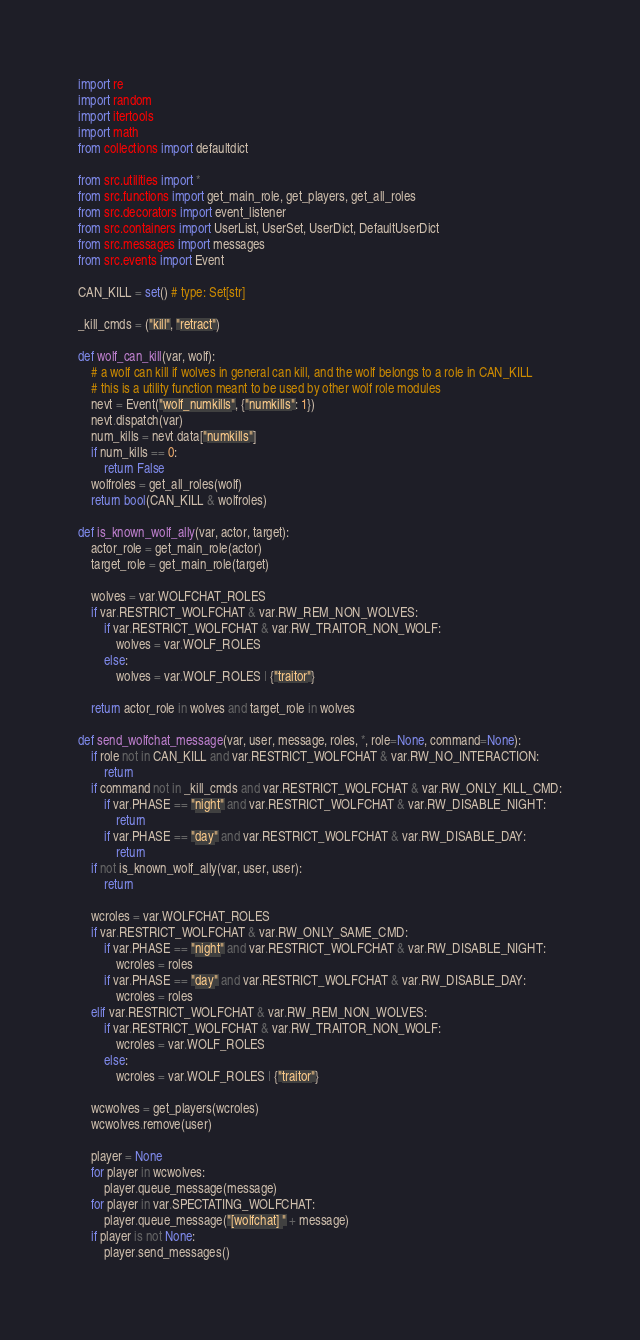<code> <loc_0><loc_0><loc_500><loc_500><_Python_>import re
import random
import itertools
import math
from collections import defaultdict

from src.utilities import *
from src.functions import get_main_role, get_players, get_all_roles
from src.decorators import event_listener
from src.containers import UserList, UserSet, UserDict, DefaultUserDict
from src.messages import messages
from src.events import Event

CAN_KILL = set() # type: Set[str]

_kill_cmds = ("kill", "retract")

def wolf_can_kill(var, wolf):
    # a wolf can kill if wolves in general can kill, and the wolf belongs to a role in CAN_KILL
    # this is a utility function meant to be used by other wolf role modules
    nevt = Event("wolf_numkills", {"numkills": 1})
    nevt.dispatch(var)
    num_kills = nevt.data["numkills"]
    if num_kills == 0:
        return False
    wolfroles = get_all_roles(wolf)
    return bool(CAN_KILL & wolfroles)

def is_known_wolf_ally(var, actor, target):
    actor_role = get_main_role(actor)
    target_role = get_main_role(target)

    wolves = var.WOLFCHAT_ROLES
    if var.RESTRICT_WOLFCHAT & var.RW_REM_NON_WOLVES:
        if var.RESTRICT_WOLFCHAT & var.RW_TRAITOR_NON_WOLF:
            wolves = var.WOLF_ROLES
        else:
            wolves = var.WOLF_ROLES | {"traitor"}

    return actor_role in wolves and target_role in wolves

def send_wolfchat_message(var, user, message, roles, *, role=None, command=None):
    if role not in CAN_KILL and var.RESTRICT_WOLFCHAT & var.RW_NO_INTERACTION:
        return
    if command not in _kill_cmds and var.RESTRICT_WOLFCHAT & var.RW_ONLY_KILL_CMD:
        if var.PHASE == "night" and var.RESTRICT_WOLFCHAT & var.RW_DISABLE_NIGHT:
            return
        if var.PHASE == "day" and var.RESTRICT_WOLFCHAT & var.RW_DISABLE_DAY:
            return
    if not is_known_wolf_ally(var, user, user):
        return

    wcroles = var.WOLFCHAT_ROLES
    if var.RESTRICT_WOLFCHAT & var.RW_ONLY_SAME_CMD:
        if var.PHASE == "night" and var.RESTRICT_WOLFCHAT & var.RW_DISABLE_NIGHT:
            wcroles = roles
        if var.PHASE == "day" and var.RESTRICT_WOLFCHAT & var.RW_DISABLE_DAY:
            wcroles = roles
    elif var.RESTRICT_WOLFCHAT & var.RW_REM_NON_WOLVES:
        if var.RESTRICT_WOLFCHAT & var.RW_TRAITOR_NON_WOLF:
            wcroles = var.WOLF_ROLES
        else:
            wcroles = var.WOLF_ROLES | {"traitor"}

    wcwolves = get_players(wcroles)
    wcwolves.remove(user)

    player = None
    for player in wcwolves:
        player.queue_message(message)
    for player in var.SPECTATING_WOLFCHAT:
        player.queue_message("[wolfchat] " + message)
    if player is not None:
        player.send_messages()
</code> 